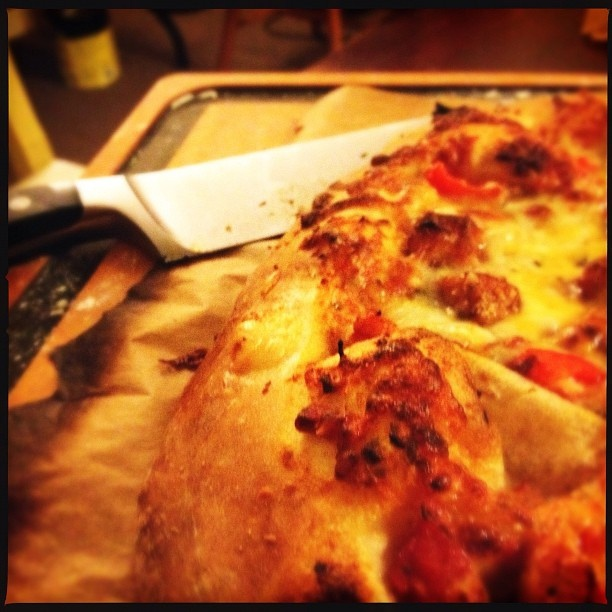Describe the objects in this image and their specific colors. I can see pizza in black, red, orange, brown, and maroon tones and knife in black, beige, khaki, and tan tones in this image. 